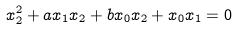<formula> <loc_0><loc_0><loc_500><loc_500>x _ { 2 } ^ { 2 } + a x _ { 1 } x _ { 2 } + b x _ { 0 } x _ { 2 } + x _ { 0 } x _ { 1 } = 0</formula> 